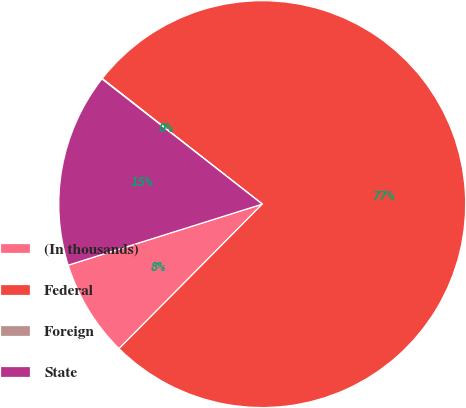Convert chart to OTSL. <chart><loc_0><loc_0><loc_500><loc_500><pie_chart><fcel>(In thousands)<fcel>Federal<fcel>Foreign<fcel>State<nl><fcel>7.72%<fcel>76.84%<fcel>0.04%<fcel>15.4%<nl></chart> 